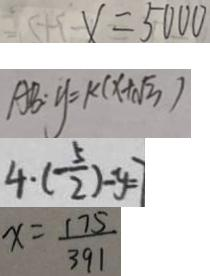Convert formula to latex. <formula><loc_0><loc_0><loc_500><loc_500>x = 5 0 0 0 
 A B : y = k ( x + \sqrt { 3 } ) 
 4 \cdot ( \frac { 5 } { 2 } ) - y = 7 
 x = \frac { 1 7 5 } { 3 9 1 }</formula> 